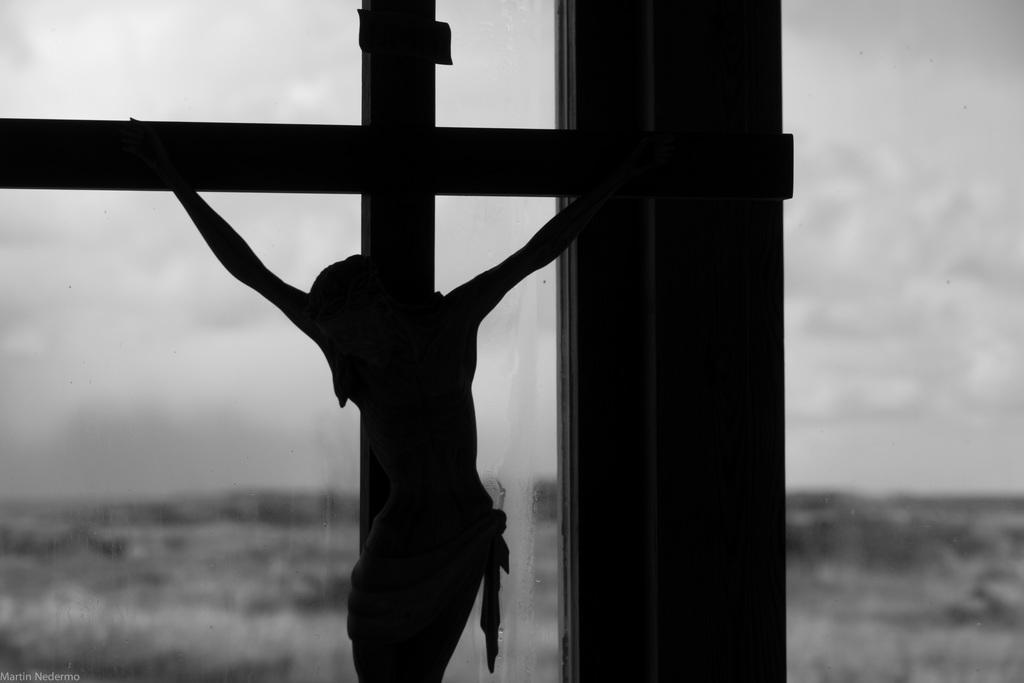Please provide a concise description of this image. In the image we can see there is a statue of jesus christ hanged to the cross kept in front and behind there is a window. The image is in black and white colour. 